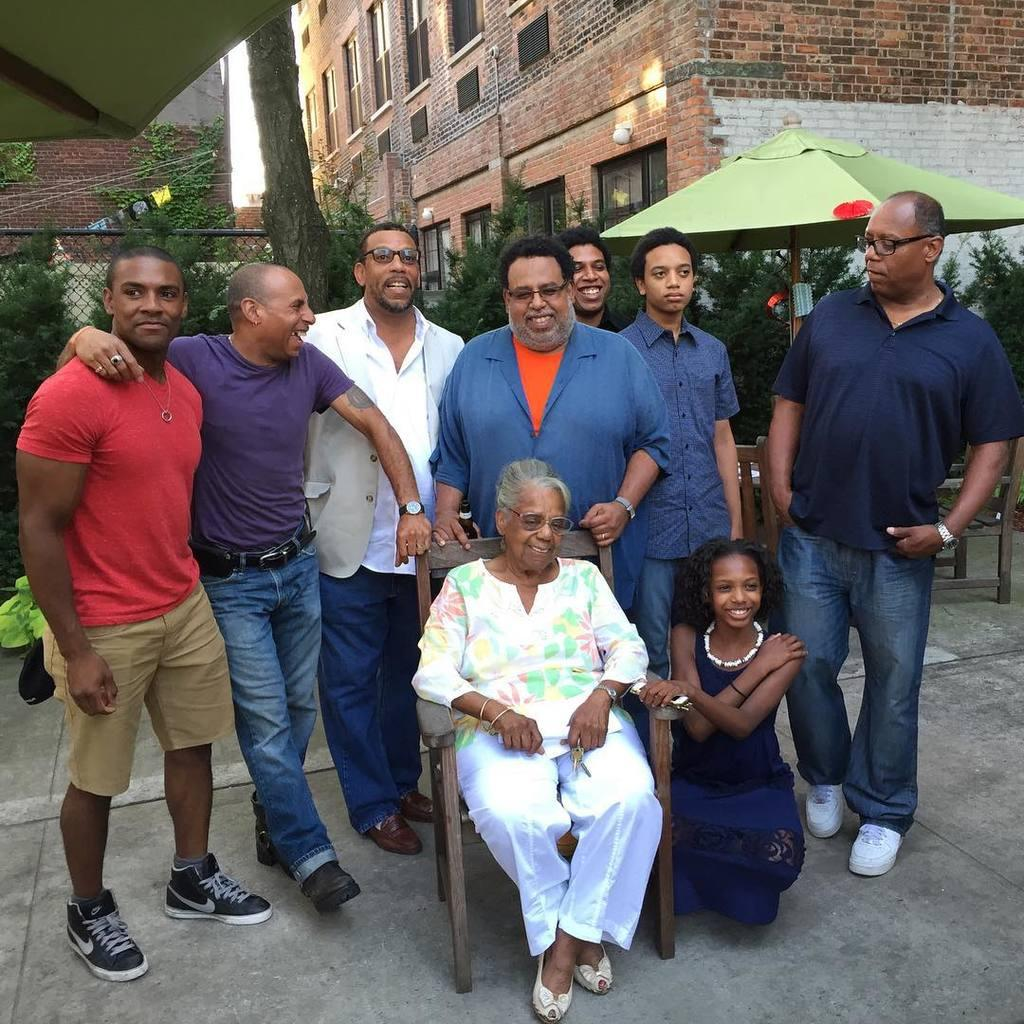What are the people in the image doing? There are persons standing on the floor and persons sitting in the image. What can be seen in the background of the image? Buildings, the sky, trees, grills, a parasol, plants, and pipelines are visible in the background. What is the surface that the people are standing or sitting on? The floor is visible in the image. What type of badge is the person wearing in the image? There is no person wearing a badge in the image. Can you tell me how many flames are visible in the image? There are no flames present in the image. 